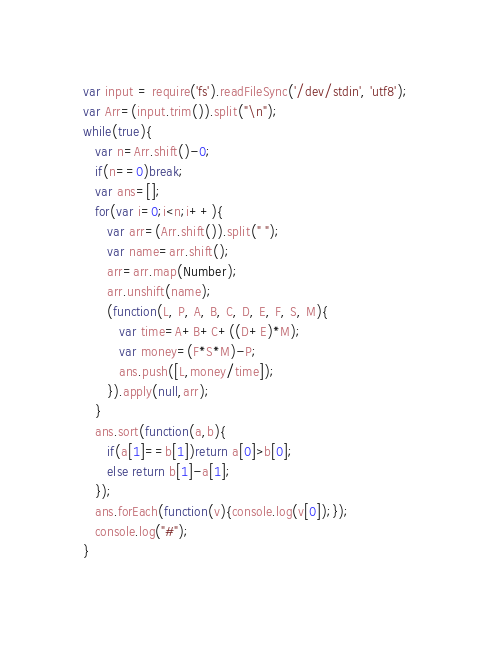Convert code to text. <code><loc_0><loc_0><loc_500><loc_500><_JavaScript_>var input = require('fs').readFileSync('/dev/stdin', 'utf8');
var Arr=(input.trim()).split("\n");
while(true){
   var n=Arr.shift()-0;
   if(n==0)break;
   var ans=[];
   for(var i=0;i<n;i++){
      var arr=(Arr.shift()).split(" ");
      var name=arr.shift();
      arr=arr.map(Number);
      arr.unshift(name);
      (function(L, P, A, B, C, D, E, F, S, M){
         var time=A+B+C+((D+E)*M);
         var money=(F*S*M)-P;
         ans.push([L,money/time]);
      }).apply(null,arr);
   }
   ans.sort(function(a,b){
      if(a[1]==b[1])return a[0]>b[0];
      else return b[1]-a[1];
   });
   ans.forEach(function(v){console.log(v[0]);});
   console.log("#");
}</code> 